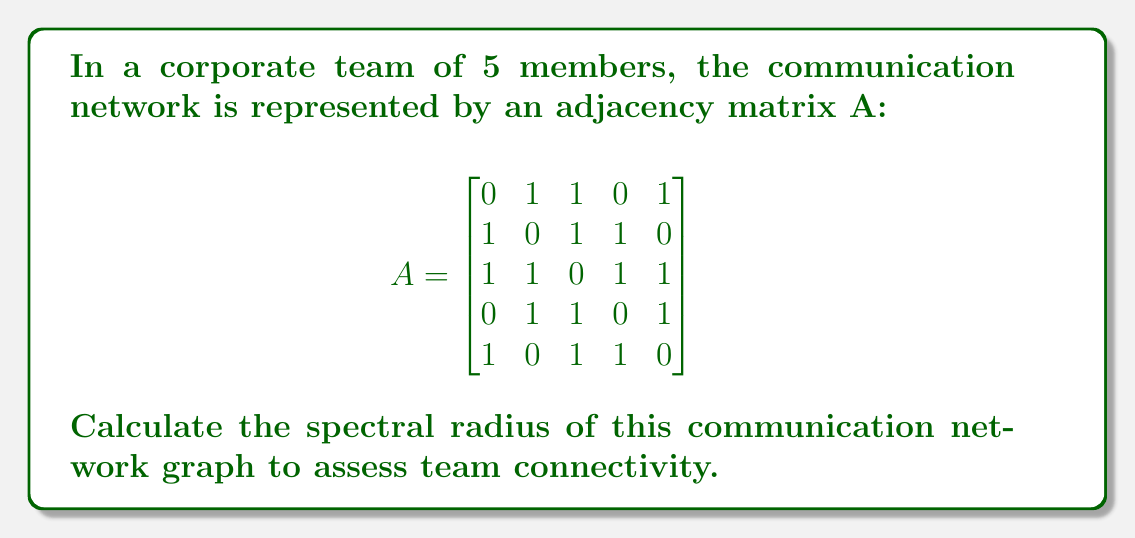Can you answer this question? To calculate the spectral radius of the communication network graph:

1. Find the eigenvalues of the adjacency matrix A:
   - Characteristic equation: $det(A - \lambda I) = 0$
   - Solve: $\lambda^5 - 12\lambda^3 - 16\lambda = 0$
   - Factor: $\lambda(\lambda^4 - 12\lambda^2 - 16) = 0$
   - Solve: $\lambda = 0$ or $\lambda^2 = 6 \pm \sqrt{52}$

2. Eigenvalues:
   $\lambda_1 = \sqrt{6 + \sqrt{52}} \approx 3.3166$
   $\lambda_2 = -\sqrt{6 + \sqrt{52}} \approx -3.3166$
   $\lambda_3 = \sqrt{6 - \sqrt{52}} \approx 0.6180$
   $\lambda_4 = -\sqrt{6 - \sqrt{52}} \approx -0.6180$
   $\lambda_5 = 0$

3. The spectral radius is the largest absolute eigenvalue:
   $\rho(A) = \max(|\lambda_i|) = \sqrt{6 + \sqrt{52}} \approx 3.3166$

This value indicates a moderately high level of team connectivity.
Answer: $\sqrt{6 + \sqrt{52}} \approx 3.3166$ 